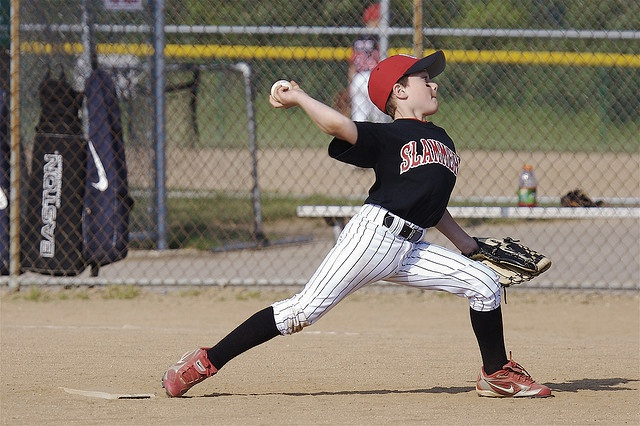Describe the objects in this image and their specific colors. I can see people in darkblue, black, white, darkgray, and gray tones, bench in darkblue, lightgray, darkgray, and gray tones, baseball glove in darkblue, black, darkgray, gray, and lightgray tones, people in darkblue, darkgray, lightgray, brown, and gray tones, and bottle in darkblue, darkgray, gray, and olive tones in this image. 